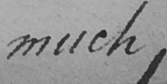Can you read and transcribe this handwriting? much , 